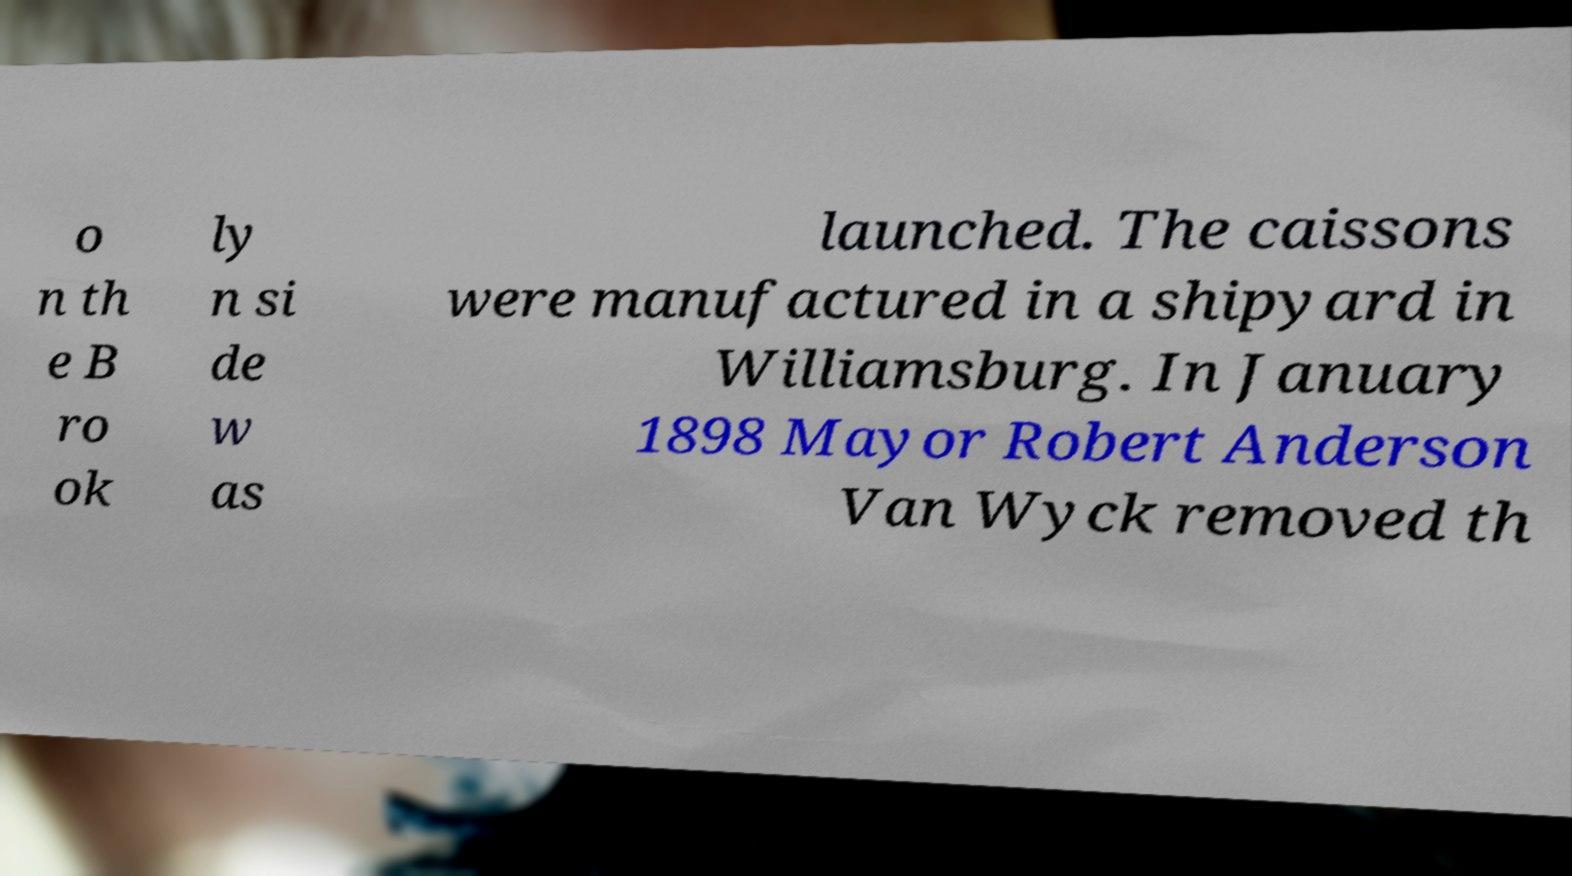I need the written content from this picture converted into text. Can you do that? o n th e B ro ok ly n si de w as launched. The caissons were manufactured in a shipyard in Williamsburg. In January 1898 Mayor Robert Anderson Van Wyck removed th 